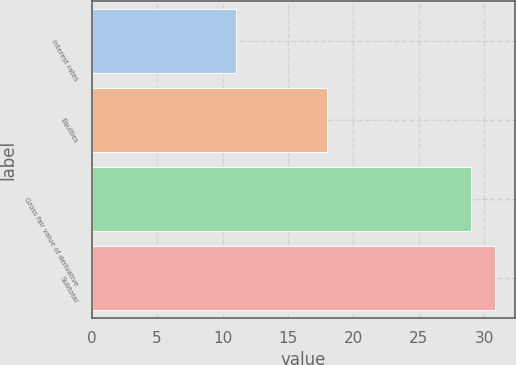Convert chart to OTSL. <chart><loc_0><loc_0><loc_500><loc_500><bar_chart><fcel>Interest rates<fcel>Equities<fcel>Gross fair value of derivative<fcel>Subtotal<nl><fcel>11<fcel>18<fcel>29<fcel>30.8<nl></chart> 